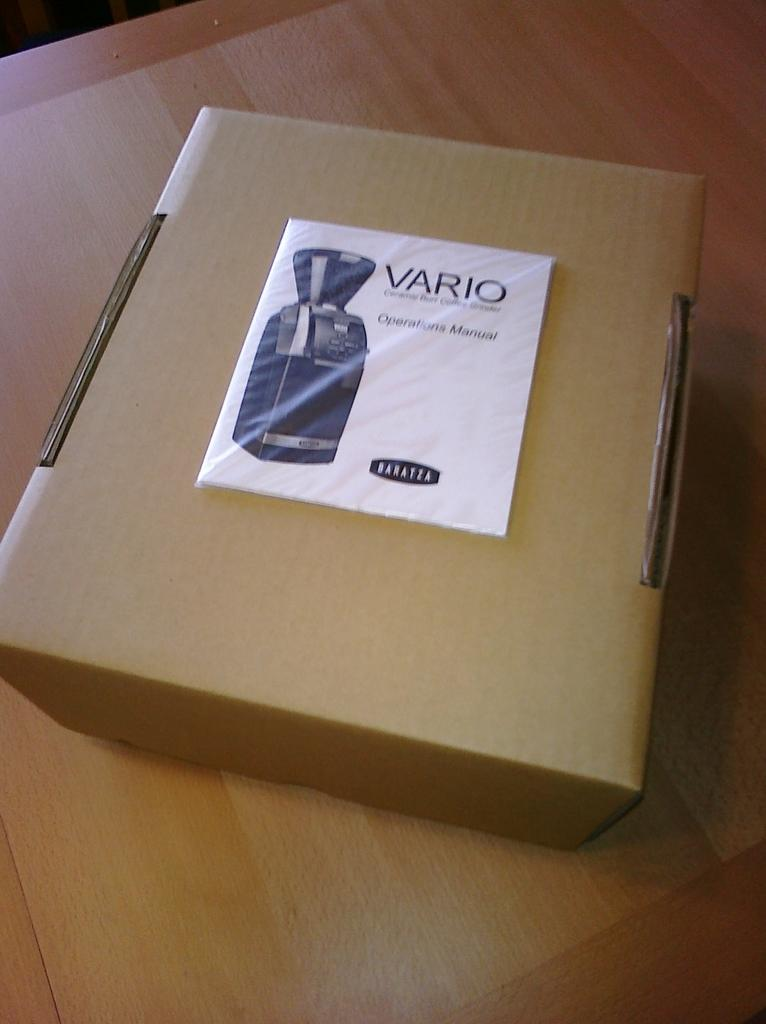What object is present in the image that is made of cardboard? There is a cardboard box in the image. Where is the cardboard box located in the image? The cardboard box is placed on a table. What type of tub is visible in the image? There is no tub present in the image. 